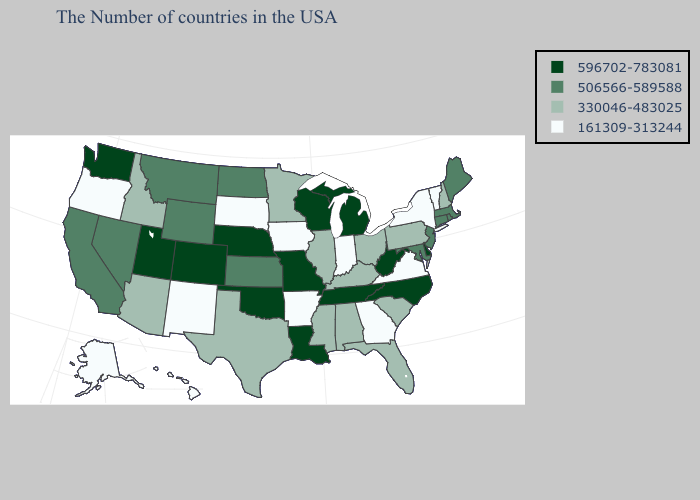Is the legend a continuous bar?
Write a very short answer. No. Is the legend a continuous bar?
Short answer required. No. Does North Dakota have the highest value in the MidWest?
Answer briefly. No. What is the highest value in the USA?
Give a very brief answer. 596702-783081. Does Delaware have the same value as Iowa?
Keep it brief. No. What is the highest value in states that border Florida?
Answer briefly. 330046-483025. Among the states that border Nebraska , which have the lowest value?
Answer briefly. Iowa, South Dakota. Among the states that border Minnesota , which have the lowest value?
Short answer required. Iowa, South Dakota. Name the states that have a value in the range 330046-483025?
Be succinct. New Hampshire, Pennsylvania, South Carolina, Ohio, Florida, Kentucky, Alabama, Illinois, Mississippi, Minnesota, Texas, Arizona, Idaho. Among the states that border Kentucky , which have the lowest value?
Answer briefly. Virginia, Indiana. What is the value of Louisiana?
Quick response, please. 596702-783081. Which states have the lowest value in the USA?
Keep it brief. Vermont, New York, Virginia, Georgia, Indiana, Arkansas, Iowa, South Dakota, New Mexico, Oregon, Alaska, Hawaii. How many symbols are there in the legend?
Write a very short answer. 4. What is the value of Iowa?
Quick response, please. 161309-313244. 